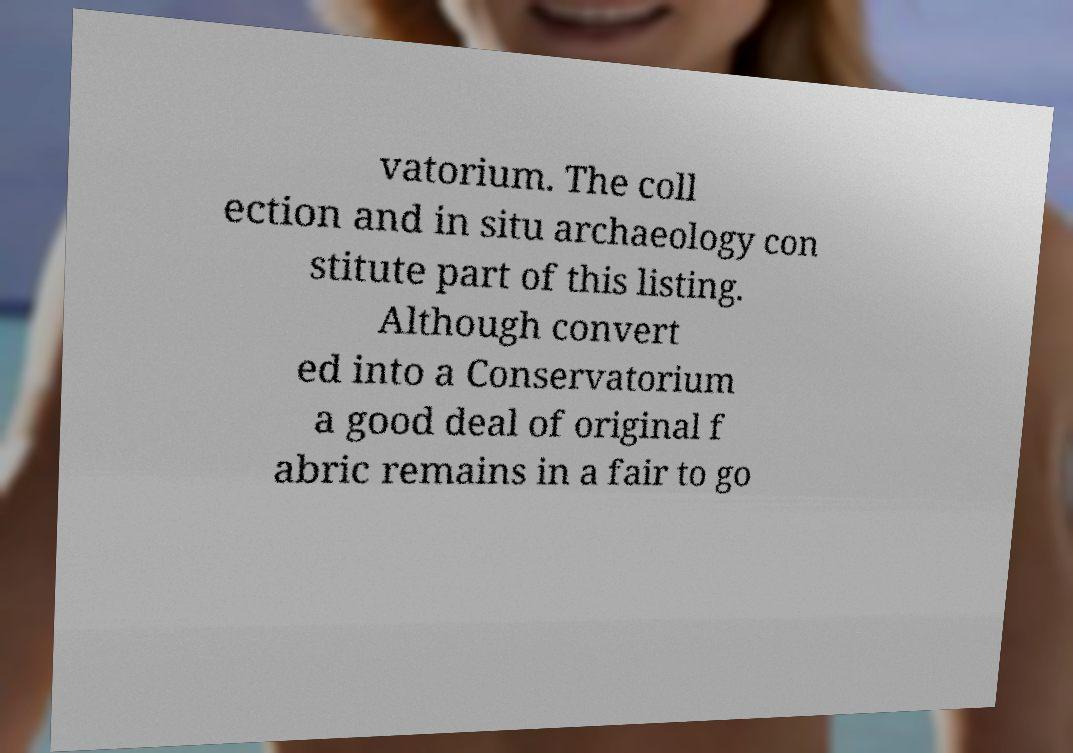I need the written content from this picture converted into text. Can you do that? vatorium. The coll ection and in situ archaeology con stitute part of this listing. Although convert ed into a Conservatorium a good deal of original f abric remains in a fair to go 